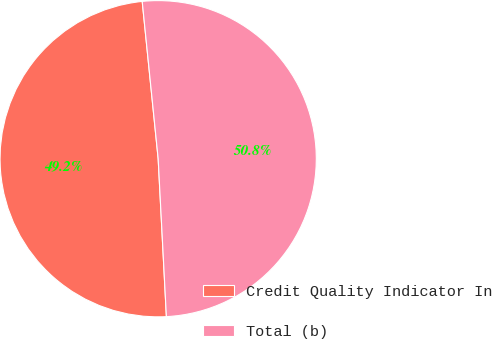Convert chart. <chart><loc_0><loc_0><loc_500><loc_500><pie_chart><fcel>Credit Quality Indicator In<fcel>Total (b)<nl><fcel>49.22%<fcel>50.78%<nl></chart> 